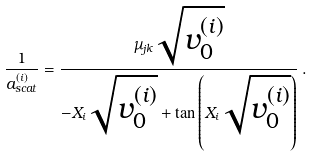Convert formula to latex. <formula><loc_0><loc_0><loc_500><loc_500>\frac { 1 } { a _ { s c a t } ^ { ( i ) } } = \frac { \mu _ { j k } \sqrt { v _ { 0 } ^ { ( i ) } } } { - X _ { i } \sqrt { v _ { 0 } ^ { ( i ) } } + \tan \left ( { X _ { i } \sqrt { v _ { 0 } ^ { ( i ) } } } \right ) } \, .</formula> 